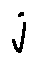Convert formula to latex. <formula><loc_0><loc_0><loc_500><loc_500>j</formula> 